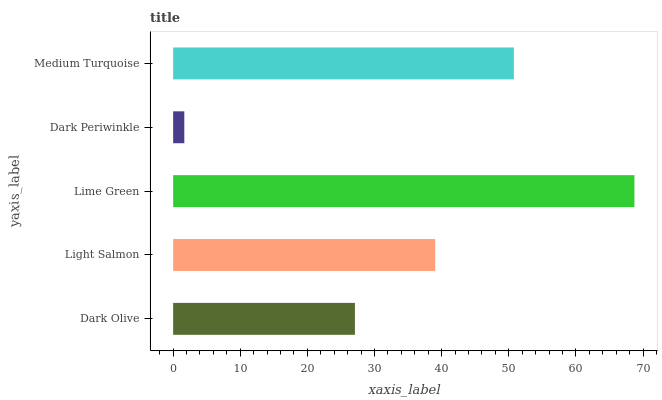Is Dark Periwinkle the minimum?
Answer yes or no. Yes. Is Lime Green the maximum?
Answer yes or no. Yes. Is Light Salmon the minimum?
Answer yes or no. No. Is Light Salmon the maximum?
Answer yes or no. No. Is Light Salmon greater than Dark Olive?
Answer yes or no. Yes. Is Dark Olive less than Light Salmon?
Answer yes or no. Yes. Is Dark Olive greater than Light Salmon?
Answer yes or no. No. Is Light Salmon less than Dark Olive?
Answer yes or no. No. Is Light Salmon the high median?
Answer yes or no. Yes. Is Light Salmon the low median?
Answer yes or no. Yes. Is Lime Green the high median?
Answer yes or no. No. Is Lime Green the low median?
Answer yes or no. No. 